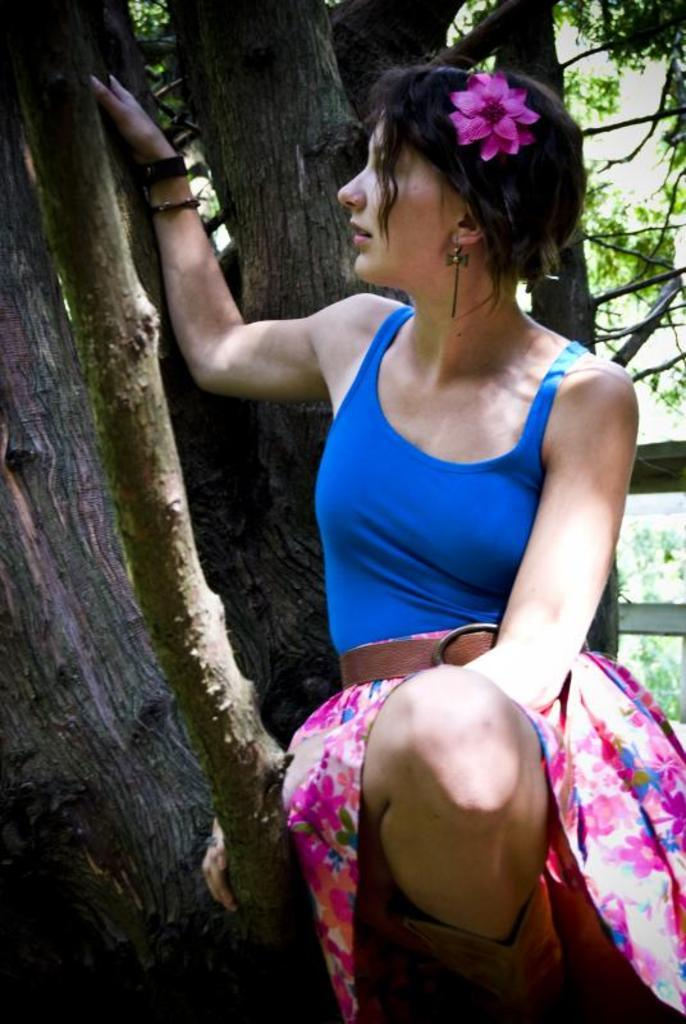What can be seen in the background of the image? There are trees in the background of the image. What part of the trees is visible on the left side of the image? Tree trunks are visible on the left side of the image. Who is present in the image? There is a woman in the image. What is the woman doing with the tree trunk? The woman has her hand on a tree trunk. What is the woman's posture or position in the image? The woman is giving a pose. Can you tell me where the mom is holding the hammer in the image? There is no mom or hammer present in the image. What type of ball is the woman holding in the image? There is no ball present in the image. 